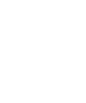Convert code to text. <code><loc_0><loc_0><loc_500><loc_500><_Nim_>







































</code> 